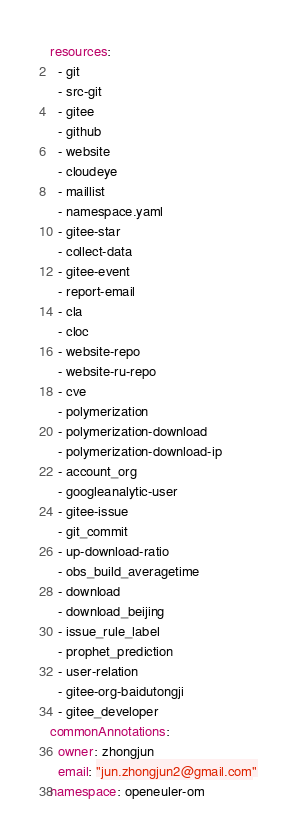Convert code to text. <code><loc_0><loc_0><loc_500><loc_500><_YAML_>resources:
  - git
  - src-git
  - gitee
  - github
  - website
  - cloudeye
  - maillist
  - namespace.yaml
  - gitee-star
  - collect-data
  - gitee-event
  - report-email
  - cla
  - cloc
  - website-repo
  - website-ru-repo
  - cve
  - polymerization
  - polymerization-download
  - polymerization-download-ip
  - account_org
  - googleanalytic-user
  - gitee-issue
  - git_commit
  - up-download-ratio
  - obs_build_averagetime
  - download
  - download_beijing
  - issue_rule_label
  - prophet_prediction
  - user-relation
  - gitee-org-baidutongji
  - gitee_developer
commonAnnotations:
  owner: zhongjun
  email: "jun.zhongjun2@gmail.com"
namespace: openeuler-om
</code> 